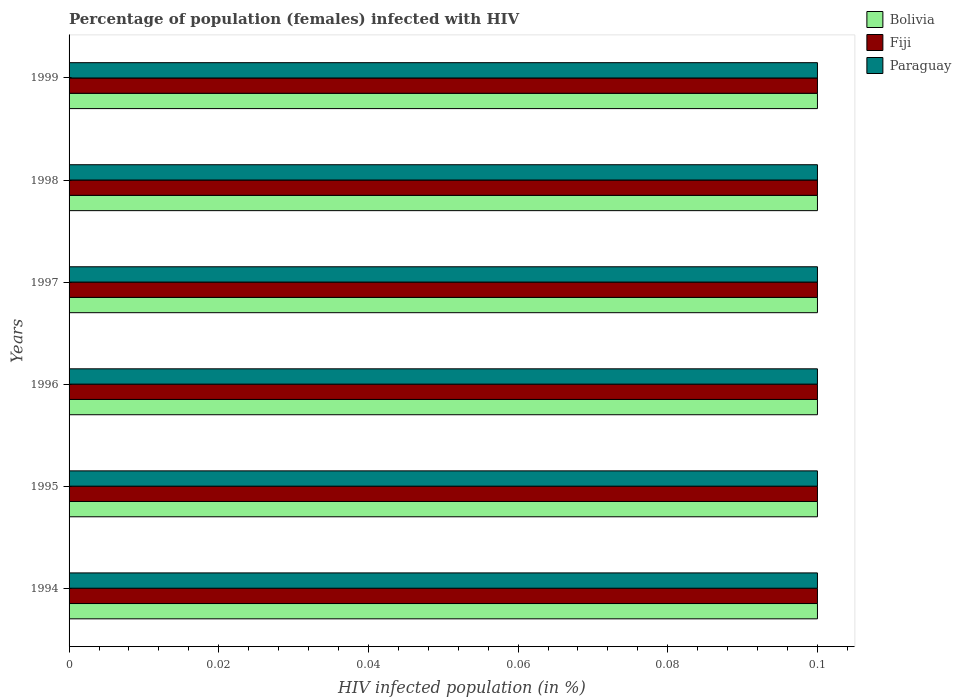How many different coloured bars are there?
Your response must be concise. 3. How many groups of bars are there?
Your response must be concise. 6. Are the number of bars on each tick of the Y-axis equal?
Your answer should be very brief. Yes. What is the label of the 5th group of bars from the top?
Make the answer very short. 1995. What is the percentage of HIV infected female population in Fiji in 1997?
Give a very brief answer. 0.1. In which year was the percentage of HIV infected female population in Paraguay maximum?
Provide a succinct answer. 1994. In which year was the percentage of HIV infected female population in Fiji minimum?
Provide a succinct answer. 1994. What is the difference between the percentage of HIV infected female population in Bolivia in 1997 and that in 1999?
Give a very brief answer. 0. What is the average percentage of HIV infected female population in Fiji per year?
Your response must be concise. 0.1. In how many years, is the percentage of HIV infected female population in Fiji greater than 0.068 %?
Make the answer very short. 6. What does the 2nd bar from the top in 1997 represents?
Offer a terse response. Fiji. What does the 1st bar from the bottom in 1997 represents?
Provide a short and direct response. Bolivia. Are all the bars in the graph horizontal?
Keep it short and to the point. Yes. How many years are there in the graph?
Your response must be concise. 6. What is the difference between two consecutive major ticks on the X-axis?
Provide a short and direct response. 0.02. Are the values on the major ticks of X-axis written in scientific E-notation?
Keep it short and to the point. No. Does the graph contain any zero values?
Provide a succinct answer. No. Does the graph contain grids?
Make the answer very short. No. Where does the legend appear in the graph?
Your answer should be very brief. Top right. How many legend labels are there?
Ensure brevity in your answer.  3. How are the legend labels stacked?
Provide a succinct answer. Vertical. What is the title of the graph?
Offer a very short reply. Percentage of population (females) infected with HIV. What is the label or title of the X-axis?
Offer a terse response. HIV infected population (in %). What is the HIV infected population (in %) of Bolivia in 1994?
Your response must be concise. 0.1. What is the HIV infected population (in %) of Fiji in 1994?
Make the answer very short. 0.1. What is the HIV infected population (in %) in Paraguay in 1994?
Give a very brief answer. 0.1. What is the HIV infected population (in %) of Fiji in 1995?
Ensure brevity in your answer.  0.1. What is the HIV infected population (in %) of Bolivia in 1996?
Your answer should be compact. 0.1. What is the HIV infected population (in %) of Fiji in 1996?
Offer a terse response. 0.1. What is the HIV infected population (in %) in Paraguay in 1996?
Make the answer very short. 0.1. What is the HIV infected population (in %) in Paraguay in 1997?
Provide a succinct answer. 0.1. What is the HIV infected population (in %) in Paraguay in 1998?
Make the answer very short. 0.1. What is the HIV infected population (in %) in Fiji in 1999?
Give a very brief answer. 0.1. Across all years, what is the maximum HIV infected population (in %) in Fiji?
Provide a succinct answer. 0.1. Across all years, what is the maximum HIV infected population (in %) in Paraguay?
Give a very brief answer. 0.1. Across all years, what is the minimum HIV infected population (in %) of Bolivia?
Provide a short and direct response. 0.1. Across all years, what is the minimum HIV infected population (in %) in Paraguay?
Ensure brevity in your answer.  0.1. What is the difference between the HIV infected population (in %) of Bolivia in 1994 and that in 1995?
Offer a very short reply. 0. What is the difference between the HIV infected population (in %) in Fiji in 1994 and that in 1995?
Keep it short and to the point. 0. What is the difference between the HIV infected population (in %) in Fiji in 1994 and that in 1997?
Your answer should be compact. 0. What is the difference between the HIV infected population (in %) of Paraguay in 1994 and that in 1997?
Your response must be concise. 0. What is the difference between the HIV infected population (in %) in Bolivia in 1994 and that in 1998?
Provide a succinct answer. 0. What is the difference between the HIV infected population (in %) in Paraguay in 1994 and that in 1999?
Your response must be concise. 0. What is the difference between the HIV infected population (in %) of Bolivia in 1995 and that in 1996?
Give a very brief answer. 0. What is the difference between the HIV infected population (in %) in Bolivia in 1995 and that in 1997?
Make the answer very short. 0. What is the difference between the HIV infected population (in %) in Fiji in 1995 and that in 1998?
Keep it short and to the point. 0. What is the difference between the HIV infected population (in %) in Fiji in 1995 and that in 1999?
Offer a very short reply. 0. What is the difference between the HIV infected population (in %) of Paraguay in 1995 and that in 1999?
Keep it short and to the point. 0. What is the difference between the HIV infected population (in %) of Bolivia in 1996 and that in 1997?
Your response must be concise. 0. What is the difference between the HIV infected population (in %) of Paraguay in 1996 and that in 1997?
Ensure brevity in your answer.  0. What is the difference between the HIV infected population (in %) of Bolivia in 1996 and that in 1998?
Ensure brevity in your answer.  0. What is the difference between the HIV infected population (in %) of Fiji in 1996 and that in 1999?
Ensure brevity in your answer.  0. What is the difference between the HIV infected population (in %) in Bolivia in 1997 and that in 1998?
Offer a terse response. 0. What is the difference between the HIV infected population (in %) of Fiji in 1997 and that in 1998?
Give a very brief answer. 0. What is the difference between the HIV infected population (in %) of Bolivia in 1997 and that in 1999?
Ensure brevity in your answer.  0. What is the difference between the HIV infected population (in %) of Fiji in 1997 and that in 1999?
Offer a very short reply. 0. What is the difference between the HIV infected population (in %) of Paraguay in 1997 and that in 1999?
Your response must be concise. 0. What is the difference between the HIV infected population (in %) of Paraguay in 1998 and that in 1999?
Offer a terse response. 0. What is the difference between the HIV infected population (in %) of Bolivia in 1994 and the HIV infected population (in %) of Fiji in 1996?
Your answer should be very brief. 0. What is the difference between the HIV infected population (in %) in Bolivia in 1994 and the HIV infected population (in %) in Paraguay in 1996?
Your answer should be compact. 0. What is the difference between the HIV infected population (in %) in Fiji in 1994 and the HIV infected population (in %) in Paraguay in 1996?
Make the answer very short. 0. What is the difference between the HIV infected population (in %) in Bolivia in 1994 and the HIV infected population (in %) in Paraguay in 1997?
Your answer should be compact. 0. What is the difference between the HIV infected population (in %) of Fiji in 1994 and the HIV infected population (in %) of Paraguay in 1997?
Your response must be concise. 0. What is the difference between the HIV infected population (in %) of Bolivia in 1994 and the HIV infected population (in %) of Fiji in 1998?
Provide a short and direct response. 0. What is the difference between the HIV infected population (in %) of Fiji in 1994 and the HIV infected population (in %) of Paraguay in 1998?
Offer a very short reply. 0. What is the difference between the HIV infected population (in %) of Bolivia in 1994 and the HIV infected population (in %) of Fiji in 1999?
Provide a short and direct response. 0. What is the difference between the HIV infected population (in %) of Bolivia in 1995 and the HIV infected population (in %) of Fiji in 1996?
Make the answer very short. 0. What is the difference between the HIV infected population (in %) in Fiji in 1995 and the HIV infected population (in %) in Paraguay in 1996?
Your response must be concise. 0. What is the difference between the HIV infected population (in %) of Bolivia in 1995 and the HIV infected population (in %) of Paraguay in 1997?
Your answer should be compact. 0. What is the difference between the HIV infected population (in %) of Fiji in 1995 and the HIV infected population (in %) of Paraguay in 1997?
Ensure brevity in your answer.  0. What is the difference between the HIV infected population (in %) in Bolivia in 1995 and the HIV infected population (in %) in Paraguay in 1998?
Make the answer very short. 0. What is the difference between the HIV infected population (in %) of Fiji in 1995 and the HIV infected population (in %) of Paraguay in 1998?
Keep it short and to the point. 0. What is the difference between the HIV infected population (in %) in Bolivia in 1995 and the HIV infected population (in %) in Fiji in 1999?
Your answer should be very brief. 0. What is the difference between the HIV infected population (in %) of Fiji in 1995 and the HIV infected population (in %) of Paraguay in 1999?
Your answer should be compact. 0. What is the difference between the HIV infected population (in %) in Bolivia in 1996 and the HIV infected population (in %) in Paraguay in 1997?
Give a very brief answer. 0. What is the difference between the HIV infected population (in %) in Fiji in 1996 and the HIV infected population (in %) in Paraguay in 1997?
Offer a very short reply. 0. What is the difference between the HIV infected population (in %) of Fiji in 1996 and the HIV infected population (in %) of Paraguay in 1998?
Make the answer very short. 0. What is the difference between the HIV infected population (in %) in Fiji in 1996 and the HIV infected population (in %) in Paraguay in 1999?
Provide a short and direct response. 0. What is the difference between the HIV infected population (in %) in Bolivia in 1997 and the HIV infected population (in %) in Fiji in 1998?
Provide a succinct answer. 0. What is the difference between the HIV infected population (in %) in Fiji in 1997 and the HIV infected population (in %) in Paraguay in 1998?
Your answer should be very brief. 0. What is the difference between the HIV infected population (in %) in Bolivia in 1997 and the HIV infected population (in %) in Fiji in 1999?
Offer a terse response. 0. What is the difference between the HIV infected population (in %) in Bolivia in 1997 and the HIV infected population (in %) in Paraguay in 1999?
Offer a very short reply. 0. What is the difference between the HIV infected population (in %) of Bolivia in 1998 and the HIV infected population (in %) of Fiji in 1999?
Provide a succinct answer. 0. What is the difference between the HIV infected population (in %) of Fiji in 1998 and the HIV infected population (in %) of Paraguay in 1999?
Ensure brevity in your answer.  0. What is the average HIV infected population (in %) of Bolivia per year?
Your answer should be very brief. 0.1. What is the average HIV infected population (in %) of Fiji per year?
Keep it short and to the point. 0.1. In the year 1994, what is the difference between the HIV infected population (in %) in Bolivia and HIV infected population (in %) in Fiji?
Your response must be concise. 0. In the year 1995, what is the difference between the HIV infected population (in %) in Bolivia and HIV infected population (in %) in Paraguay?
Make the answer very short. 0. In the year 1996, what is the difference between the HIV infected population (in %) of Bolivia and HIV infected population (in %) of Paraguay?
Keep it short and to the point. 0. In the year 1996, what is the difference between the HIV infected population (in %) in Fiji and HIV infected population (in %) in Paraguay?
Provide a short and direct response. 0. In the year 1998, what is the difference between the HIV infected population (in %) in Bolivia and HIV infected population (in %) in Fiji?
Your answer should be compact. 0. In the year 1998, what is the difference between the HIV infected population (in %) in Bolivia and HIV infected population (in %) in Paraguay?
Give a very brief answer. 0. In the year 1998, what is the difference between the HIV infected population (in %) of Fiji and HIV infected population (in %) of Paraguay?
Ensure brevity in your answer.  0. In the year 1999, what is the difference between the HIV infected population (in %) of Bolivia and HIV infected population (in %) of Fiji?
Keep it short and to the point. 0. What is the ratio of the HIV infected population (in %) in Bolivia in 1994 to that in 1995?
Provide a succinct answer. 1. What is the ratio of the HIV infected population (in %) of Fiji in 1994 to that in 1995?
Provide a succinct answer. 1. What is the ratio of the HIV infected population (in %) in Paraguay in 1994 to that in 1995?
Your response must be concise. 1. What is the ratio of the HIV infected population (in %) of Bolivia in 1994 to that in 1997?
Give a very brief answer. 1. What is the ratio of the HIV infected population (in %) of Paraguay in 1994 to that in 1997?
Provide a succinct answer. 1. What is the ratio of the HIV infected population (in %) of Bolivia in 1994 to that in 1998?
Give a very brief answer. 1. What is the ratio of the HIV infected population (in %) in Fiji in 1994 to that in 1998?
Your answer should be compact. 1. What is the ratio of the HIV infected population (in %) of Fiji in 1994 to that in 1999?
Ensure brevity in your answer.  1. What is the ratio of the HIV infected population (in %) in Fiji in 1995 to that in 1996?
Provide a succinct answer. 1. What is the ratio of the HIV infected population (in %) in Paraguay in 1995 to that in 1996?
Your response must be concise. 1. What is the ratio of the HIV infected population (in %) in Fiji in 1995 to that in 1997?
Keep it short and to the point. 1. What is the ratio of the HIV infected population (in %) in Bolivia in 1995 to that in 1998?
Your response must be concise. 1. What is the ratio of the HIV infected population (in %) of Fiji in 1995 to that in 1998?
Provide a short and direct response. 1. What is the ratio of the HIV infected population (in %) in Paraguay in 1995 to that in 1998?
Your answer should be compact. 1. What is the ratio of the HIV infected population (in %) in Paraguay in 1995 to that in 1999?
Give a very brief answer. 1. What is the ratio of the HIV infected population (in %) of Paraguay in 1996 to that in 1997?
Provide a succinct answer. 1. What is the ratio of the HIV infected population (in %) of Fiji in 1996 to that in 1998?
Provide a succinct answer. 1. What is the ratio of the HIV infected population (in %) in Paraguay in 1996 to that in 1998?
Provide a succinct answer. 1. What is the ratio of the HIV infected population (in %) of Bolivia in 1996 to that in 1999?
Provide a succinct answer. 1. What is the ratio of the HIV infected population (in %) in Fiji in 1996 to that in 1999?
Provide a short and direct response. 1. What is the ratio of the HIV infected population (in %) of Paraguay in 1997 to that in 1998?
Provide a short and direct response. 1. What is the difference between the highest and the second highest HIV infected population (in %) of Bolivia?
Make the answer very short. 0. What is the difference between the highest and the second highest HIV infected population (in %) in Fiji?
Your response must be concise. 0. What is the difference between the highest and the lowest HIV infected population (in %) in Fiji?
Your answer should be very brief. 0. 